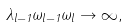<formula> <loc_0><loc_0><loc_500><loc_500>\lambda _ { l - 1 } \omega _ { l - 1 } \omega _ { l } \to \infty ,</formula> 